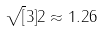<formula> <loc_0><loc_0><loc_500><loc_500>\sqrt { [ } 3 ] { 2 } \approx 1 . 2 6</formula> 